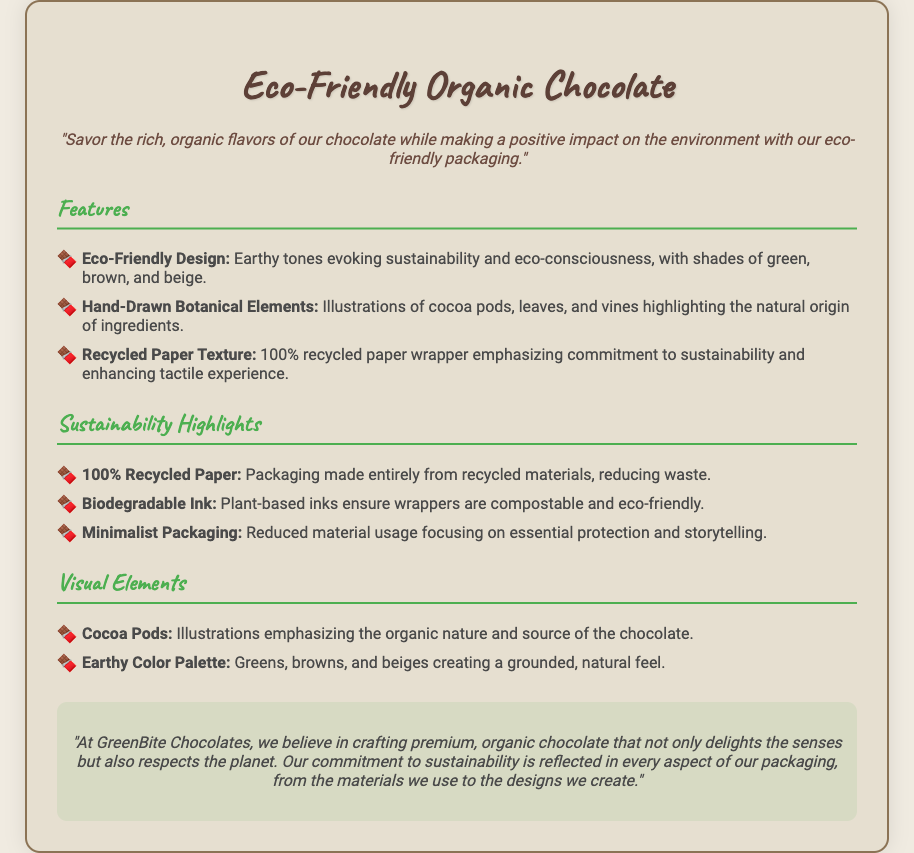What is the product name? The product name is mentioned in the header of the document, which is "Eco-Friendly Organic Chocolate."
Answer: Eco-Friendly Organic Chocolate What colors are used in the design? The design focuses on earthy tones that evoke sustainability, primarily green, brown, and beige.
Answer: Green, brown, and beige What type of paper is used for the wrapper? The document states that the wrapper is made from recycled materials, specifically emphasizing "100% recycled paper."
Answer: 100% recycled paper What elements are included in the botanical illustrations? The document lists illustrations of cocoa pods, leaves, and vines, highlighting the natural origin of ingredients.
Answer: Cocoa pods, leaves, and vines What is the brand's commitment mentioned in the document? The brand expresses that it believes in crafting premium organic chocolate that respects the planet, reflected in eco-friendly practices.
Answer: Sustainability How are the inks used in the packaging? The document specifies that the inks are plant-based, ensuring that the wrappers are compostable and eco-friendly.
Answer: Biodegradable Ink What type of packaging philosophy is mentioned? The document highlights a "Minimalist Packaging" approach focusing on reducing material usage while telling the product story.
Answer: Minimalist Packaging What is the key message of the product? The product's key message prominently conveys the enjoyment of organic chocolate while positively impacting the environment.
Answer: Savor the rich, organic flavors What is the font used for the product name? The header uses "Caveat," a cursive font, for its design to stand out.
Answer: Caveat 